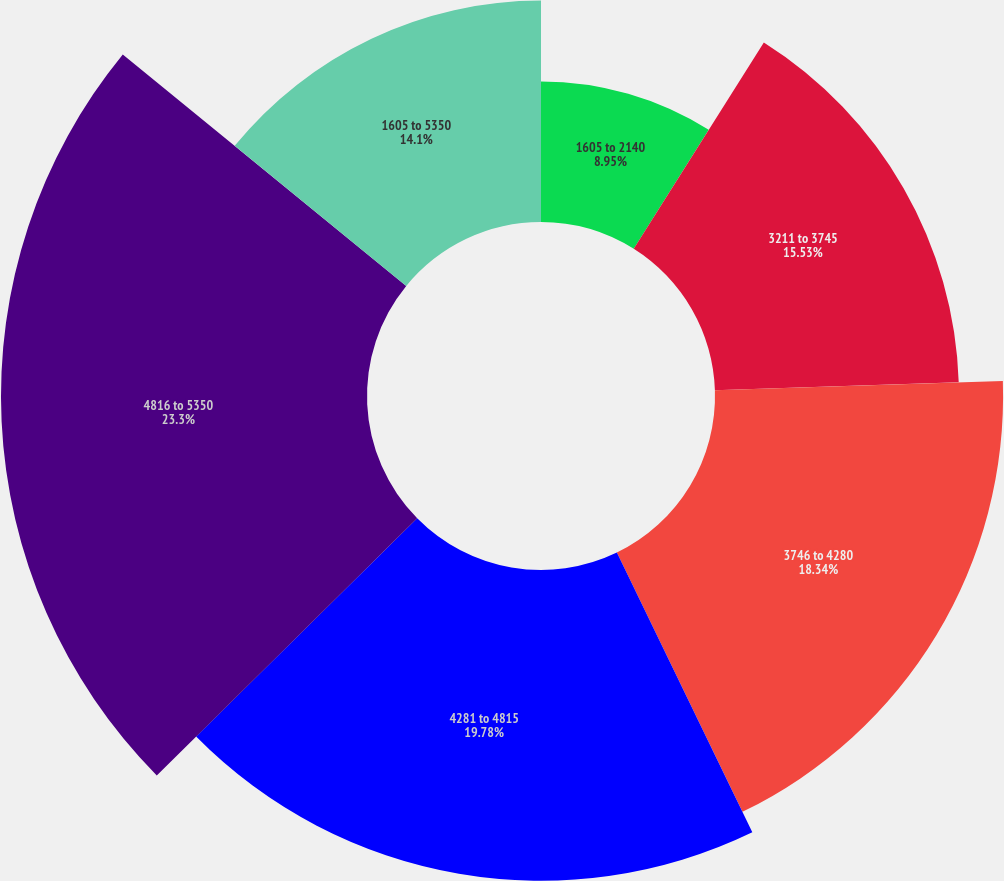Convert chart to OTSL. <chart><loc_0><loc_0><loc_500><loc_500><pie_chart><fcel>1605 to 2140<fcel>3211 to 3745<fcel>3746 to 4280<fcel>4281 to 4815<fcel>4816 to 5350<fcel>1605 to 5350<nl><fcel>8.95%<fcel>15.53%<fcel>18.34%<fcel>19.78%<fcel>23.3%<fcel>14.1%<nl></chart> 